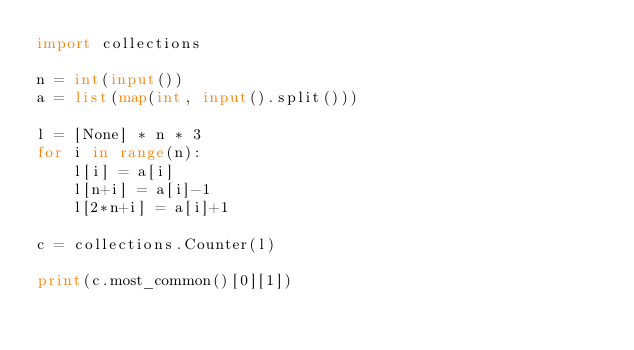<code> <loc_0><loc_0><loc_500><loc_500><_Python_>import collections

n = int(input())
a = list(map(int, input().split()))

l = [None] * n * 3
for i in range(n):
    l[i] = a[i]
    l[n+i] = a[i]-1
    l[2*n+i] = a[i]+1
    
c = collections.Counter(l)
    
print(c.most_common()[0][1])</code> 